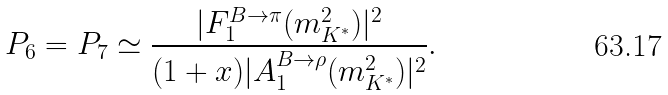Convert formula to latex. <formula><loc_0><loc_0><loc_500><loc_500>P _ { 6 } = P _ { 7 } \simeq \frac { | F _ { 1 } ^ { B \to \pi } ( m _ { K ^ { * } } ^ { 2 } ) | ^ { 2 } } { ( 1 + x ) | A _ { 1 } ^ { B \to \rho } ( m _ { K ^ { * } } ^ { 2 } ) | ^ { 2 } } .</formula> 